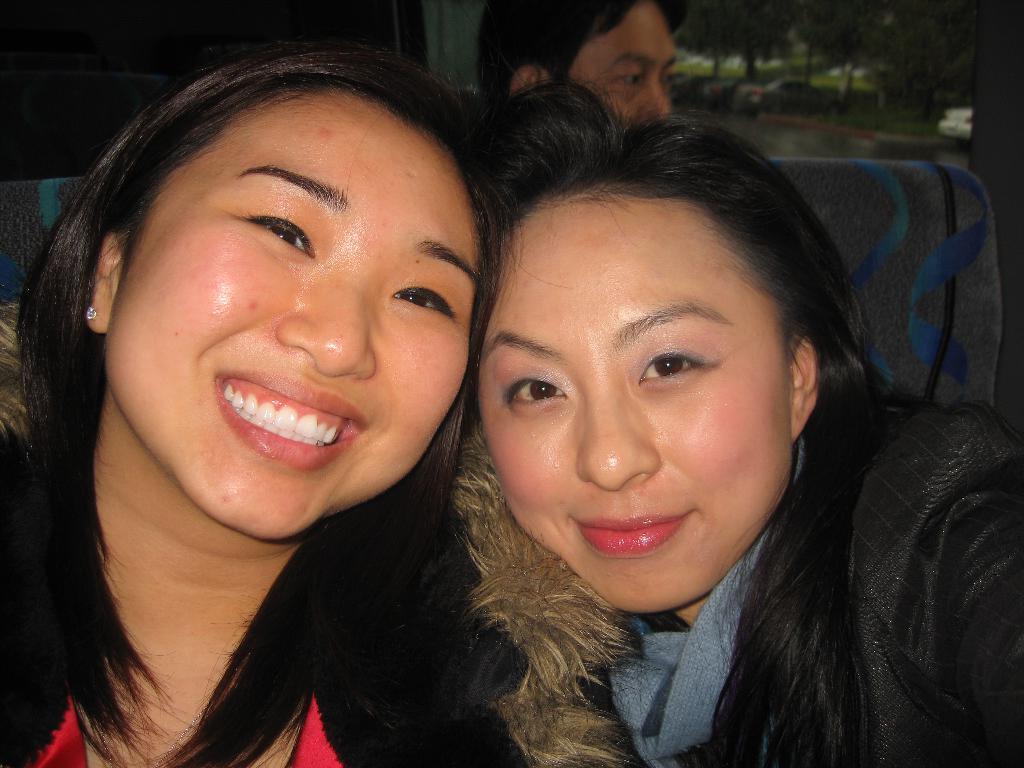Describe this image in one or two sentences. This picture looks like an inner view of a vehicle. In this image we can see two women sitting on the seats, one person's head behind the woman, some vehicles on the road, some trees in the background, the background is dark and blurred. 